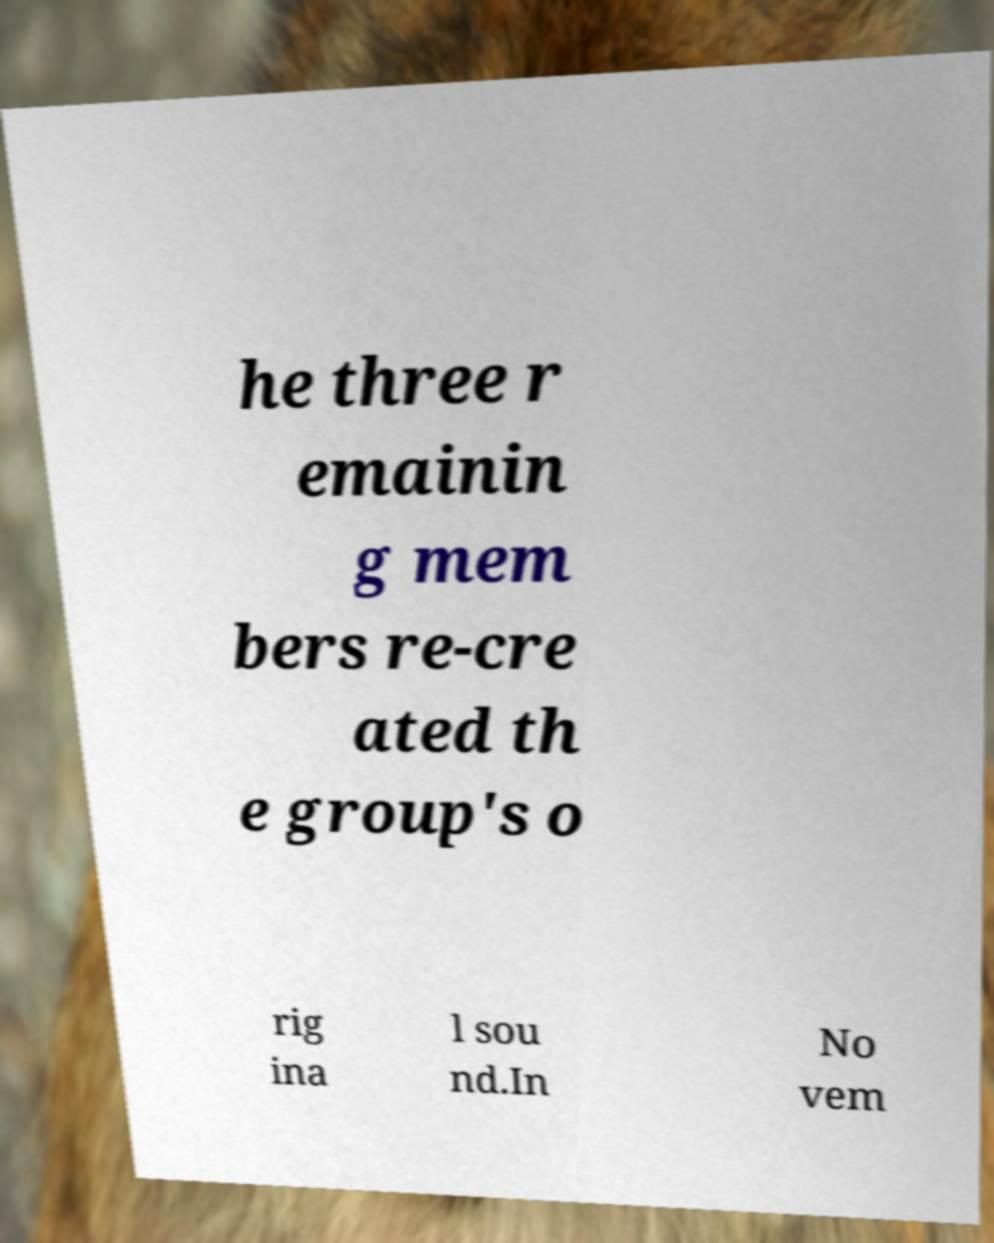For documentation purposes, I need the text within this image transcribed. Could you provide that? he three r emainin g mem bers re-cre ated th e group's o rig ina l sou nd.In No vem 